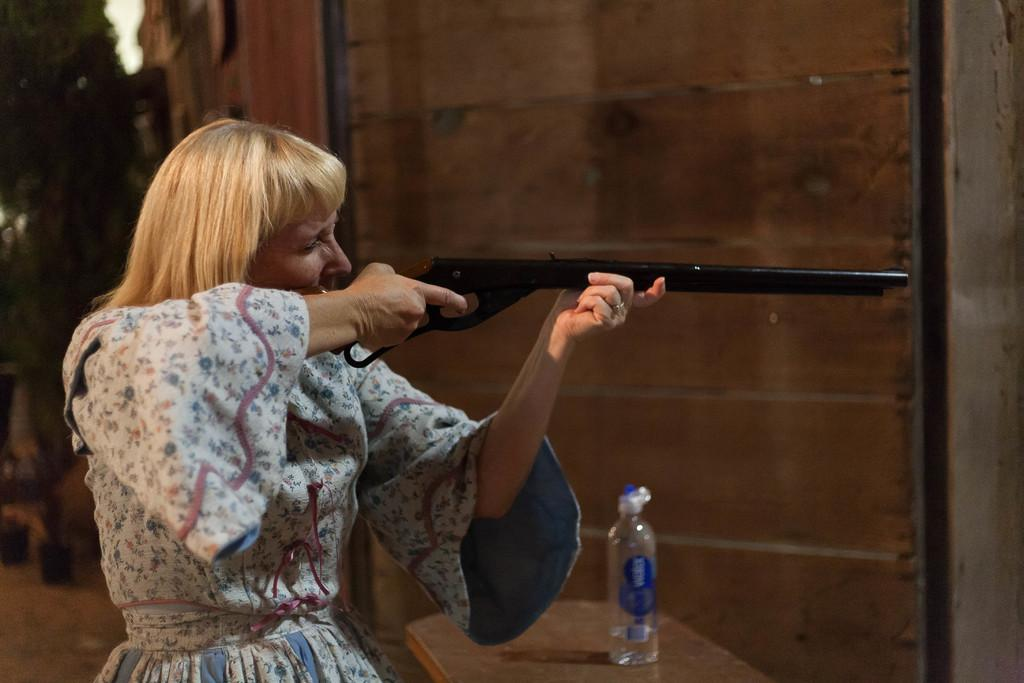Who is present in the image? There is a woman in the image. What is the woman holding in the image? The woman is holding a gun. What is the woman doing with the gun? The woman is aiming at something. What can be seen on the table in the image? There is a bottle of water on a table in the image. What type of furniture is visible in the image? There is no furniture visible in the image. What is the stem of the gun in the image? The image does not show a gun with a stem; it is a regular gun without any additional parts. 